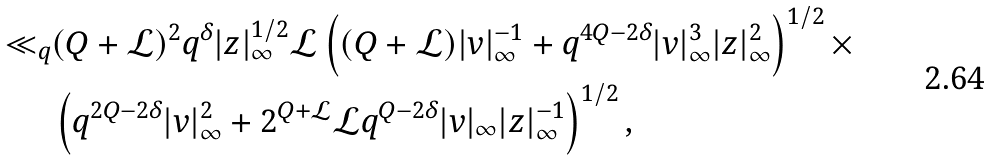<formula> <loc_0><loc_0><loc_500><loc_500>\ll _ { q } & ( Q + \mathcal { L } ) ^ { 2 } q ^ { \delta } | z | _ { \infty } ^ { 1 / 2 } \mathcal { L } \left ( ( Q + \mathcal { L } ) | v | _ { \infty } ^ { - 1 } + q ^ { 4 Q - 2 \delta } | v | _ { \infty } ^ { 3 } | z | _ { \infty } ^ { 2 } \right ) ^ { 1 / 2 } \times \\ & \left ( q ^ { 2 Q - 2 \delta } | v | _ { \infty } ^ { 2 } + 2 ^ { Q + \mathcal { L } } \mathcal { L } q ^ { Q - 2 \delta } | v | _ { \infty } | z | _ { \infty } ^ { - 1 } \right ) ^ { 1 / 2 } ,</formula> 